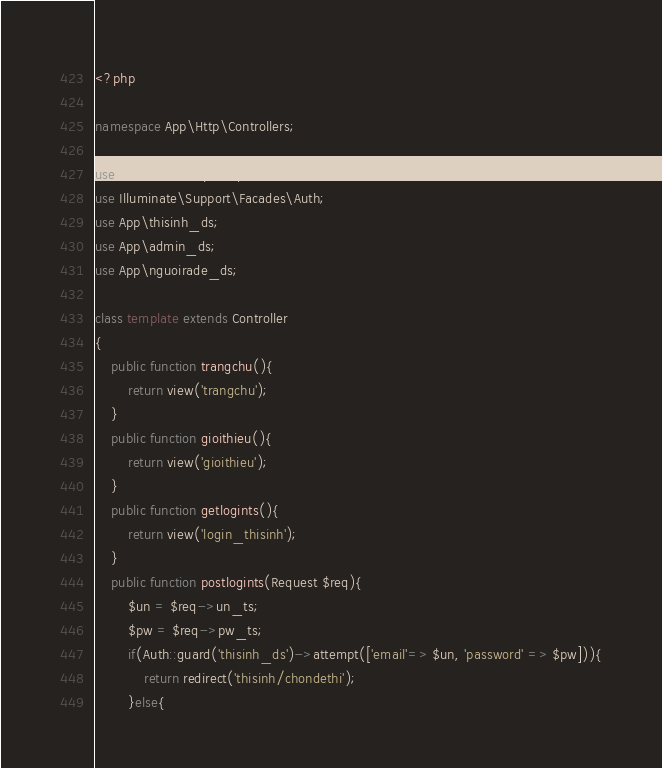Convert code to text. <code><loc_0><loc_0><loc_500><loc_500><_PHP_><?php

namespace App\Http\Controllers;

use Illuminate\Http\Request;
use Illuminate\Support\Facades\Auth;
use App\thisinh_ds;
use App\admin_ds;
use App\nguoirade_ds;

class template extends Controller
{
    public function trangchu(){
        return view('trangchu');
    }
    public function gioithieu(){
        return view('gioithieu');
    }
    public function getlogints(){
        return view('login_thisinh');
    }
    public function postlogints(Request $req){
        $un = $req->un_ts;
        $pw = $req->pw_ts;
        if(Auth::guard('thisinh_ds')->attempt(['email'=> $un, 'password' => $pw])){
            return redirect('thisinh/chondethi');
        }else{</code> 